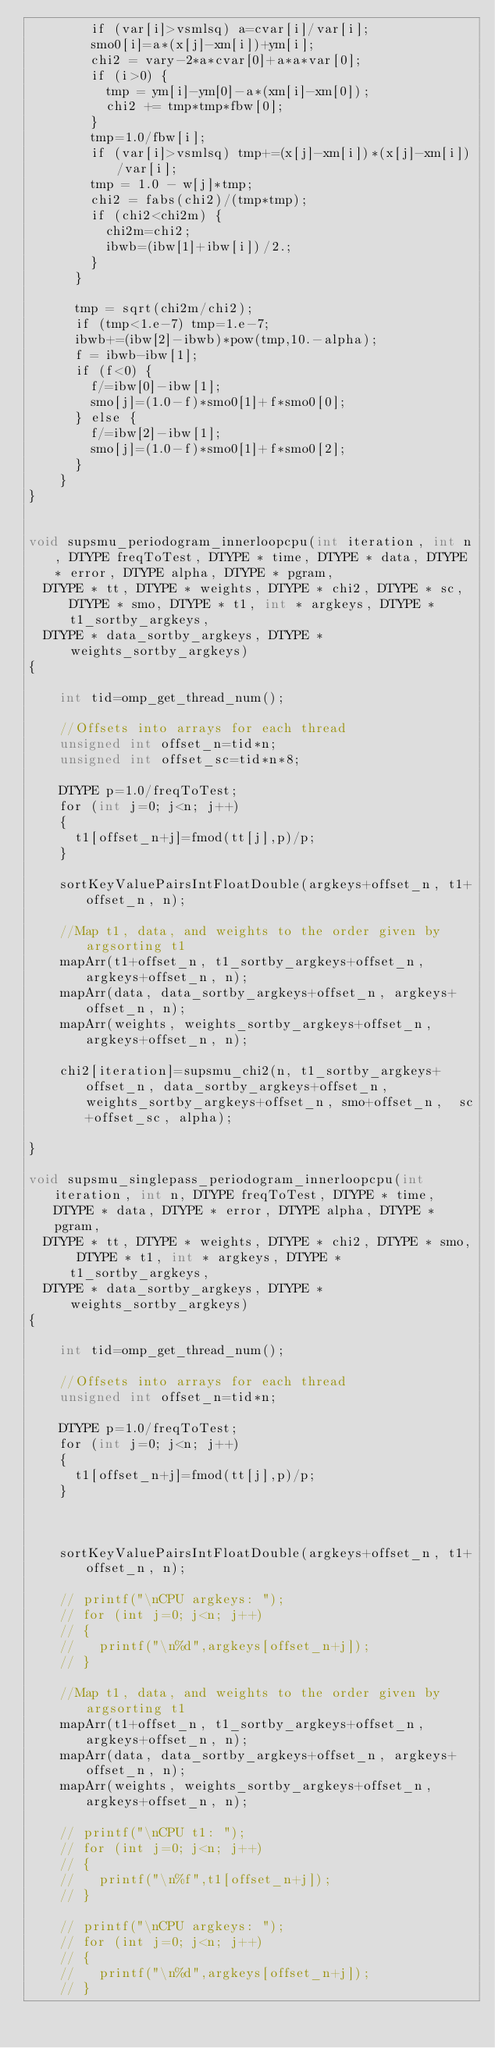<code> <loc_0><loc_0><loc_500><loc_500><_Cuda_>        if (var[i]>vsmlsq) a=cvar[i]/var[i];
        smo0[i]=a*(x[j]-xm[i])+ym[i];
        chi2 = vary-2*a*cvar[0]+a*a*var[0];
        if (i>0) {
          tmp = ym[i]-ym[0]-a*(xm[i]-xm[0]);
          chi2 += tmp*tmp*fbw[0];
        }
        tmp=1.0/fbw[i];
        if (var[i]>vsmlsq) tmp+=(x[j]-xm[i])*(x[j]-xm[i])/var[i];
        tmp = 1.0 - w[j]*tmp;
        chi2 = fabs(chi2)/(tmp*tmp);
        if (chi2<chi2m) {
          chi2m=chi2;
          ibwb=(ibw[1]+ibw[i])/2.;
        }
      }

      tmp = sqrt(chi2m/chi2);
      if (tmp<1.e-7) tmp=1.e-7;
      ibwb+=(ibw[2]-ibwb)*pow(tmp,10.-alpha);
      f = ibwb-ibw[1];
      if (f<0) {
        f/=ibw[0]-ibw[1];
        smo[j]=(1.0-f)*smo0[1]+f*smo0[0];
      } else {
        f/=ibw[2]-ibw[1];
        smo[j]=(1.0-f)*smo0[1]+f*smo0[2];
      }
    }
}


void supsmu_periodogram_innerloopcpu(int iteration, int n, DTYPE freqToTest, DTYPE * time, DTYPE * data, DTYPE * error, DTYPE alpha, DTYPE * pgram,
  DTYPE * tt, DTYPE * weights, DTYPE * chi2, DTYPE * sc, DTYPE * smo, DTYPE * t1, int * argkeys, DTYPE * t1_sortby_argkeys,
  DTYPE * data_sortby_argkeys, DTYPE * weights_sortby_argkeys)
{

    int tid=omp_get_thread_num();

    //Offsets into arrays for each thread
    unsigned int offset_n=tid*n;
    unsigned int offset_sc=tid*n*8;
    
    DTYPE p=1.0/freqToTest;
    for (int j=0; j<n; j++)
    {
      t1[offset_n+j]=fmod(tt[j],p)/p;
    }

    sortKeyValuePairsIntFloatDouble(argkeys+offset_n, t1+offset_n, n);

    //Map t1, data, and weights to the order given by argsorting t1
    mapArr(t1+offset_n, t1_sortby_argkeys+offset_n, argkeys+offset_n, n);
    mapArr(data, data_sortby_argkeys+offset_n, argkeys+offset_n, n);
    mapArr(weights, weights_sortby_argkeys+offset_n, argkeys+offset_n, n);

    chi2[iteration]=supsmu_chi2(n, t1_sortby_argkeys+offset_n, data_sortby_argkeys+offset_n, weights_sortby_argkeys+offset_n, smo+offset_n,  sc+offset_sc, alpha);
  
}

void supsmu_singlepass_periodogram_innerloopcpu(int iteration, int n, DTYPE freqToTest, DTYPE * time, DTYPE * data, DTYPE * error, DTYPE alpha, DTYPE * pgram,
  DTYPE * tt, DTYPE * weights, DTYPE * chi2, DTYPE * smo, DTYPE * t1, int * argkeys, DTYPE * t1_sortby_argkeys,
  DTYPE * data_sortby_argkeys, DTYPE * weights_sortby_argkeys)
{

    int tid=omp_get_thread_num();

    //Offsets into arrays for each thread
    unsigned int offset_n=tid*n;
    
    DTYPE p=1.0/freqToTest;
    for (int j=0; j<n; j++)
    {
      t1[offset_n+j]=fmod(tt[j],p)/p;
    }

    

    sortKeyValuePairsIntFloatDouble(argkeys+offset_n, t1+offset_n, n);

    // printf("\nCPU argkeys: ");
    // for (int j=0; j<n; j++)
    // {
    //   printf("\n%d",argkeys[offset_n+j]);
    // }

    //Map t1, data, and weights to the order given by argsorting t1
    mapArr(t1+offset_n, t1_sortby_argkeys+offset_n, argkeys+offset_n, n);
    mapArr(data, data_sortby_argkeys+offset_n, argkeys+offset_n, n);
    mapArr(weights, weights_sortby_argkeys+offset_n, argkeys+offset_n, n);

    // printf("\nCPU t1: ");
    // for (int j=0; j<n; j++)
    // {
    //   printf("\n%f",t1[offset_n+j]);
    // }

    // printf("\nCPU argkeys: ");
    // for (int j=0; j<n; j++)
    // {
    //   printf("\n%d",argkeys[offset_n+j]);
    // }

    
</code> 